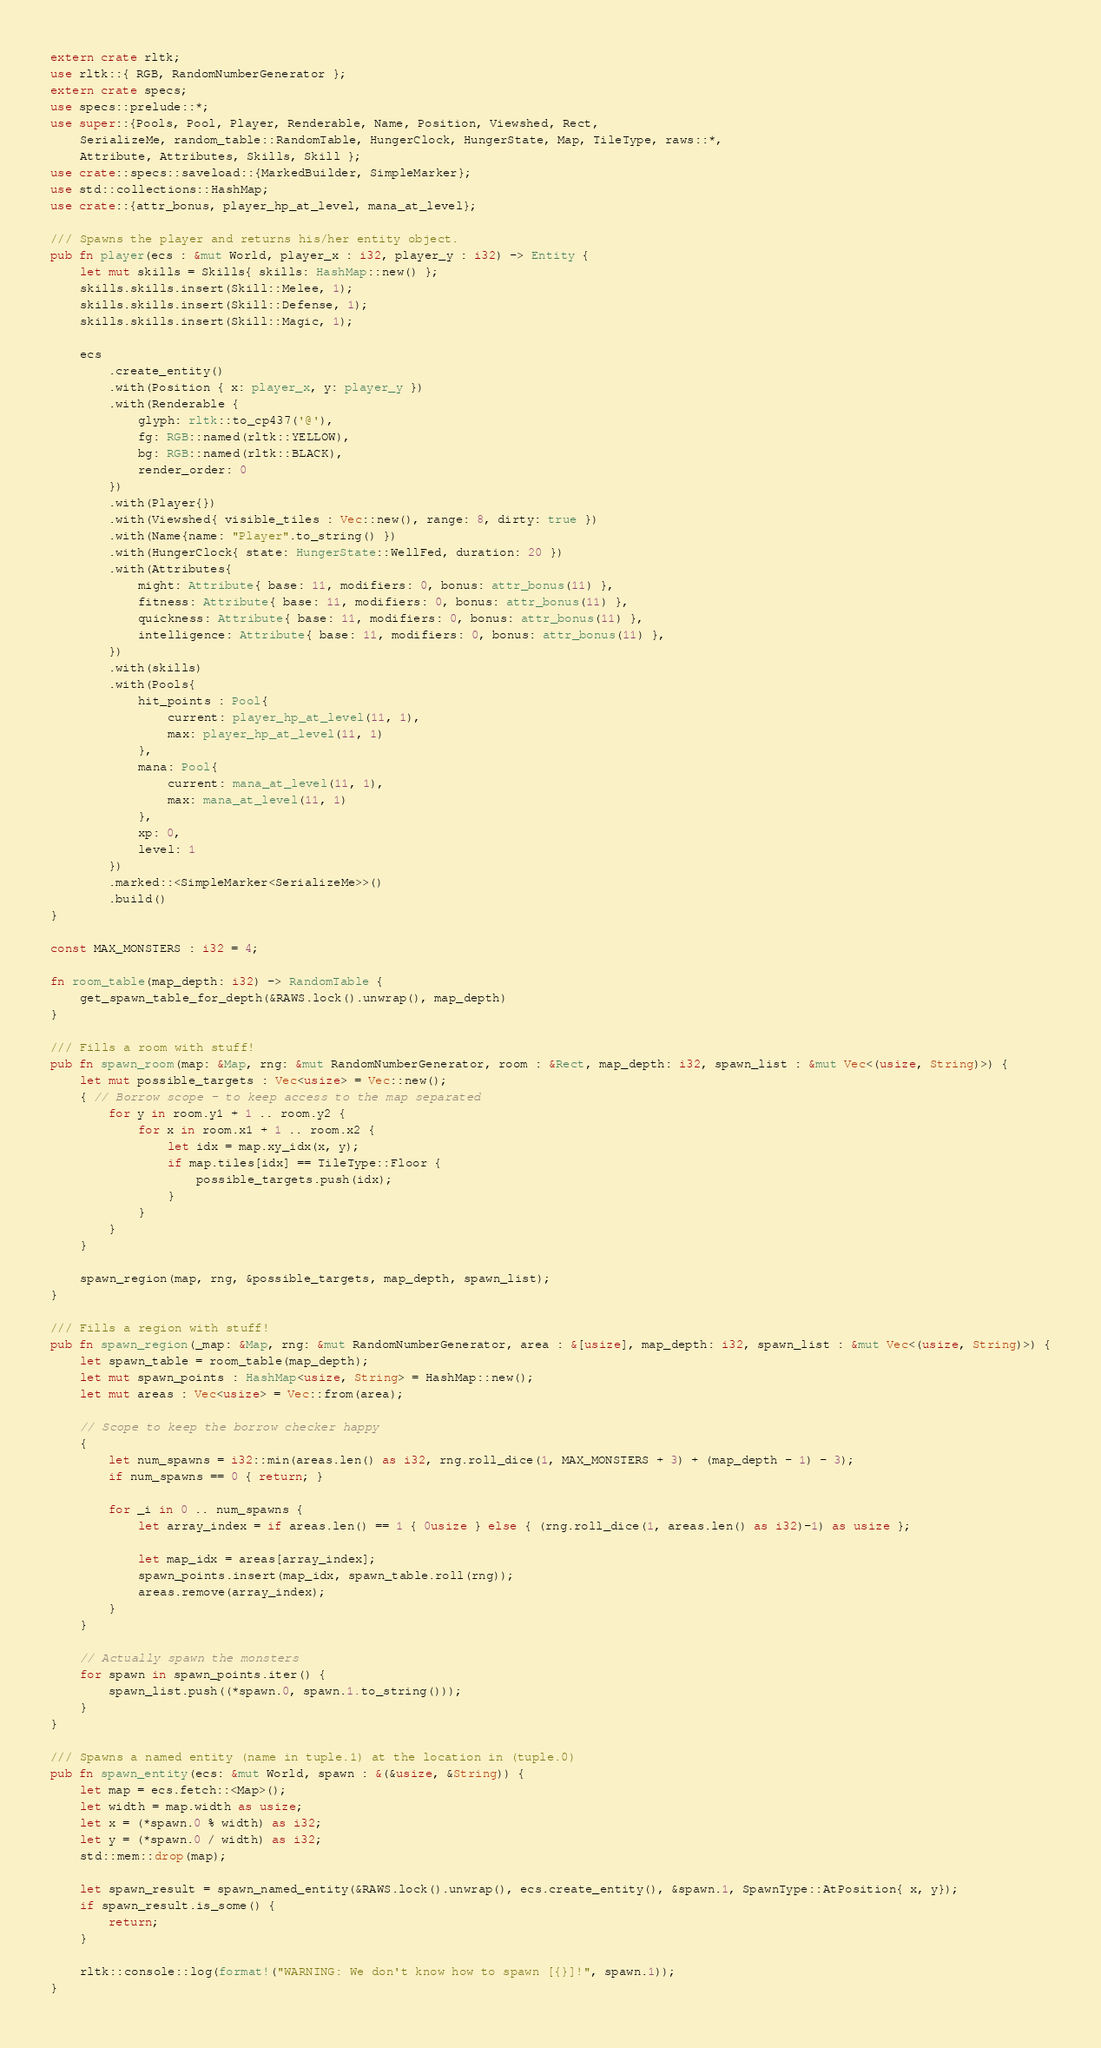<code> <loc_0><loc_0><loc_500><loc_500><_Rust_>extern crate rltk;
use rltk::{ RGB, RandomNumberGenerator };
extern crate specs;
use specs::prelude::*;
use super::{Pools, Pool, Player, Renderable, Name, Position, Viewshed, Rect,
    SerializeMe, random_table::RandomTable, HungerClock, HungerState, Map, TileType, raws::*,
    Attribute, Attributes, Skills, Skill };
use crate::specs::saveload::{MarkedBuilder, SimpleMarker};
use std::collections::HashMap;
use crate::{attr_bonus, player_hp_at_level, mana_at_level};

/// Spawns the player and returns his/her entity object.
pub fn player(ecs : &mut World, player_x : i32, player_y : i32) -> Entity {
    let mut skills = Skills{ skills: HashMap::new() };
    skills.skills.insert(Skill::Melee, 1);
    skills.skills.insert(Skill::Defense, 1);
    skills.skills.insert(Skill::Magic, 1);

    ecs
        .create_entity()
        .with(Position { x: player_x, y: player_y })
        .with(Renderable {
            glyph: rltk::to_cp437('@'),
            fg: RGB::named(rltk::YELLOW),
            bg: RGB::named(rltk::BLACK),
            render_order: 0
        })
        .with(Player{})
        .with(Viewshed{ visible_tiles : Vec::new(), range: 8, dirty: true })
        .with(Name{name: "Player".to_string() })
        .with(HungerClock{ state: HungerState::WellFed, duration: 20 })
        .with(Attributes{
            might: Attribute{ base: 11, modifiers: 0, bonus: attr_bonus(11) },
            fitness: Attribute{ base: 11, modifiers: 0, bonus: attr_bonus(11) },
            quickness: Attribute{ base: 11, modifiers: 0, bonus: attr_bonus(11) },
            intelligence: Attribute{ base: 11, modifiers: 0, bonus: attr_bonus(11) },
        })
        .with(skills)
        .with(Pools{
            hit_points : Pool{
                current: player_hp_at_level(11, 1),
                max: player_hp_at_level(11, 1)
            },
            mana: Pool{
                current: mana_at_level(11, 1),
                max: mana_at_level(11, 1)
            },
            xp: 0,
            level: 1
        })
        .marked::<SimpleMarker<SerializeMe>>()
        .build()
}

const MAX_MONSTERS : i32 = 4;

fn room_table(map_depth: i32) -> RandomTable {
    get_spawn_table_for_depth(&RAWS.lock().unwrap(), map_depth)
}

/// Fills a room with stuff!
pub fn spawn_room(map: &Map, rng: &mut RandomNumberGenerator, room : &Rect, map_depth: i32, spawn_list : &mut Vec<(usize, String)>) {
    let mut possible_targets : Vec<usize> = Vec::new();
    { // Borrow scope - to keep access to the map separated
        for y in room.y1 + 1 .. room.y2 {
            for x in room.x1 + 1 .. room.x2 {
                let idx = map.xy_idx(x, y);
                if map.tiles[idx] == TileType::Floor {
                    possible_targets.push(idx);
                }
            }
        }
    }

    spawn_region(map, rng, &possible_targets, map_depth, spawn_list);
}

/// Fills a region with stuff!
pub fn spawn_region(_map: &Map, rng: &mut RandomNumberGenerator, area : &[usize], map_depth: i32, spawn_list : &mut Vec<(usize, String)>) {
    let spawn_table = room_table(map_depth);
    let mut spawn_points : HashMap<usize, String> = HashMap::new();
    let mut areas : Vec<usize> = Vec::from(area);

    // Scope to keep the borrow checker happy
    {
        let num_spawns = i32::min(areas.len() as i32, rng.roll_dice(1, MAX_MONSTERS + 3) + (map_depth - 1) - 3);
        if num_spawns == 0 { return; }

        for _i in 0 .. num_spawns {
            let array_index = if areas.len() == 1 { 0usize } else { (rng.roll_dice(1, areas.len() as i32)-1) as usize };

            let map_idx = areas[array_index];
            spawn_points.insert(map_idx, spawn_table.roll(rng));
            areas.remove(array_index);
        }
    }

    // Actually spawn the monsters
    for spawn in spawn_points.iter() {
        spawn_list.push((*spawn.0, spawn.1.to_string()));
    }
}

/// Spawns a named entity (name in tuple.1) at the location in (tuple.0)
pub fn spawn_entity(ecs: &mut World, spawn : &(&usize, &String)) {
    let map = ecs.fetch::<Map>();
    let width = map.width as usize;
    let x = (*spawn.0 % width) as i32;
    let y = (*spawn.0 / width) as i32;
    std::mem::drop(map);

    let spawn_result = spawn_named_entity(&RAWS.lock().unwrap(), ecs.create_entity(), &spawn.1, SpawnType::AtPosition{ x, y});
    if spawn_result.is_some() {
        return;
    }

    rltk::console::log(format!("WARNING: We don't know how to spawn [{}]!", spawn.1));
}
</code> 